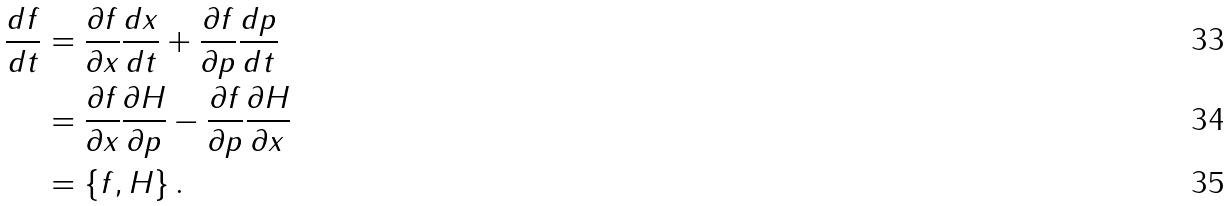Convert formula to latex. <formula><loc_0><loc_0><loc_500><loc_500>\frac { d f } { d t } & = \frac { \partial f } { \partial x } \frac { d x } { d t } + \frac { \partial f } { \partial p } \frac { d p } { d t } \\ & = \frac { \partial f } { \partial x } \frac { \partial H } { \partial p } - \frac { \partial f } { \partial p } \frac { \partial H } { \partial x } \\ & = \left \{ f , H \right \} .</formula> 